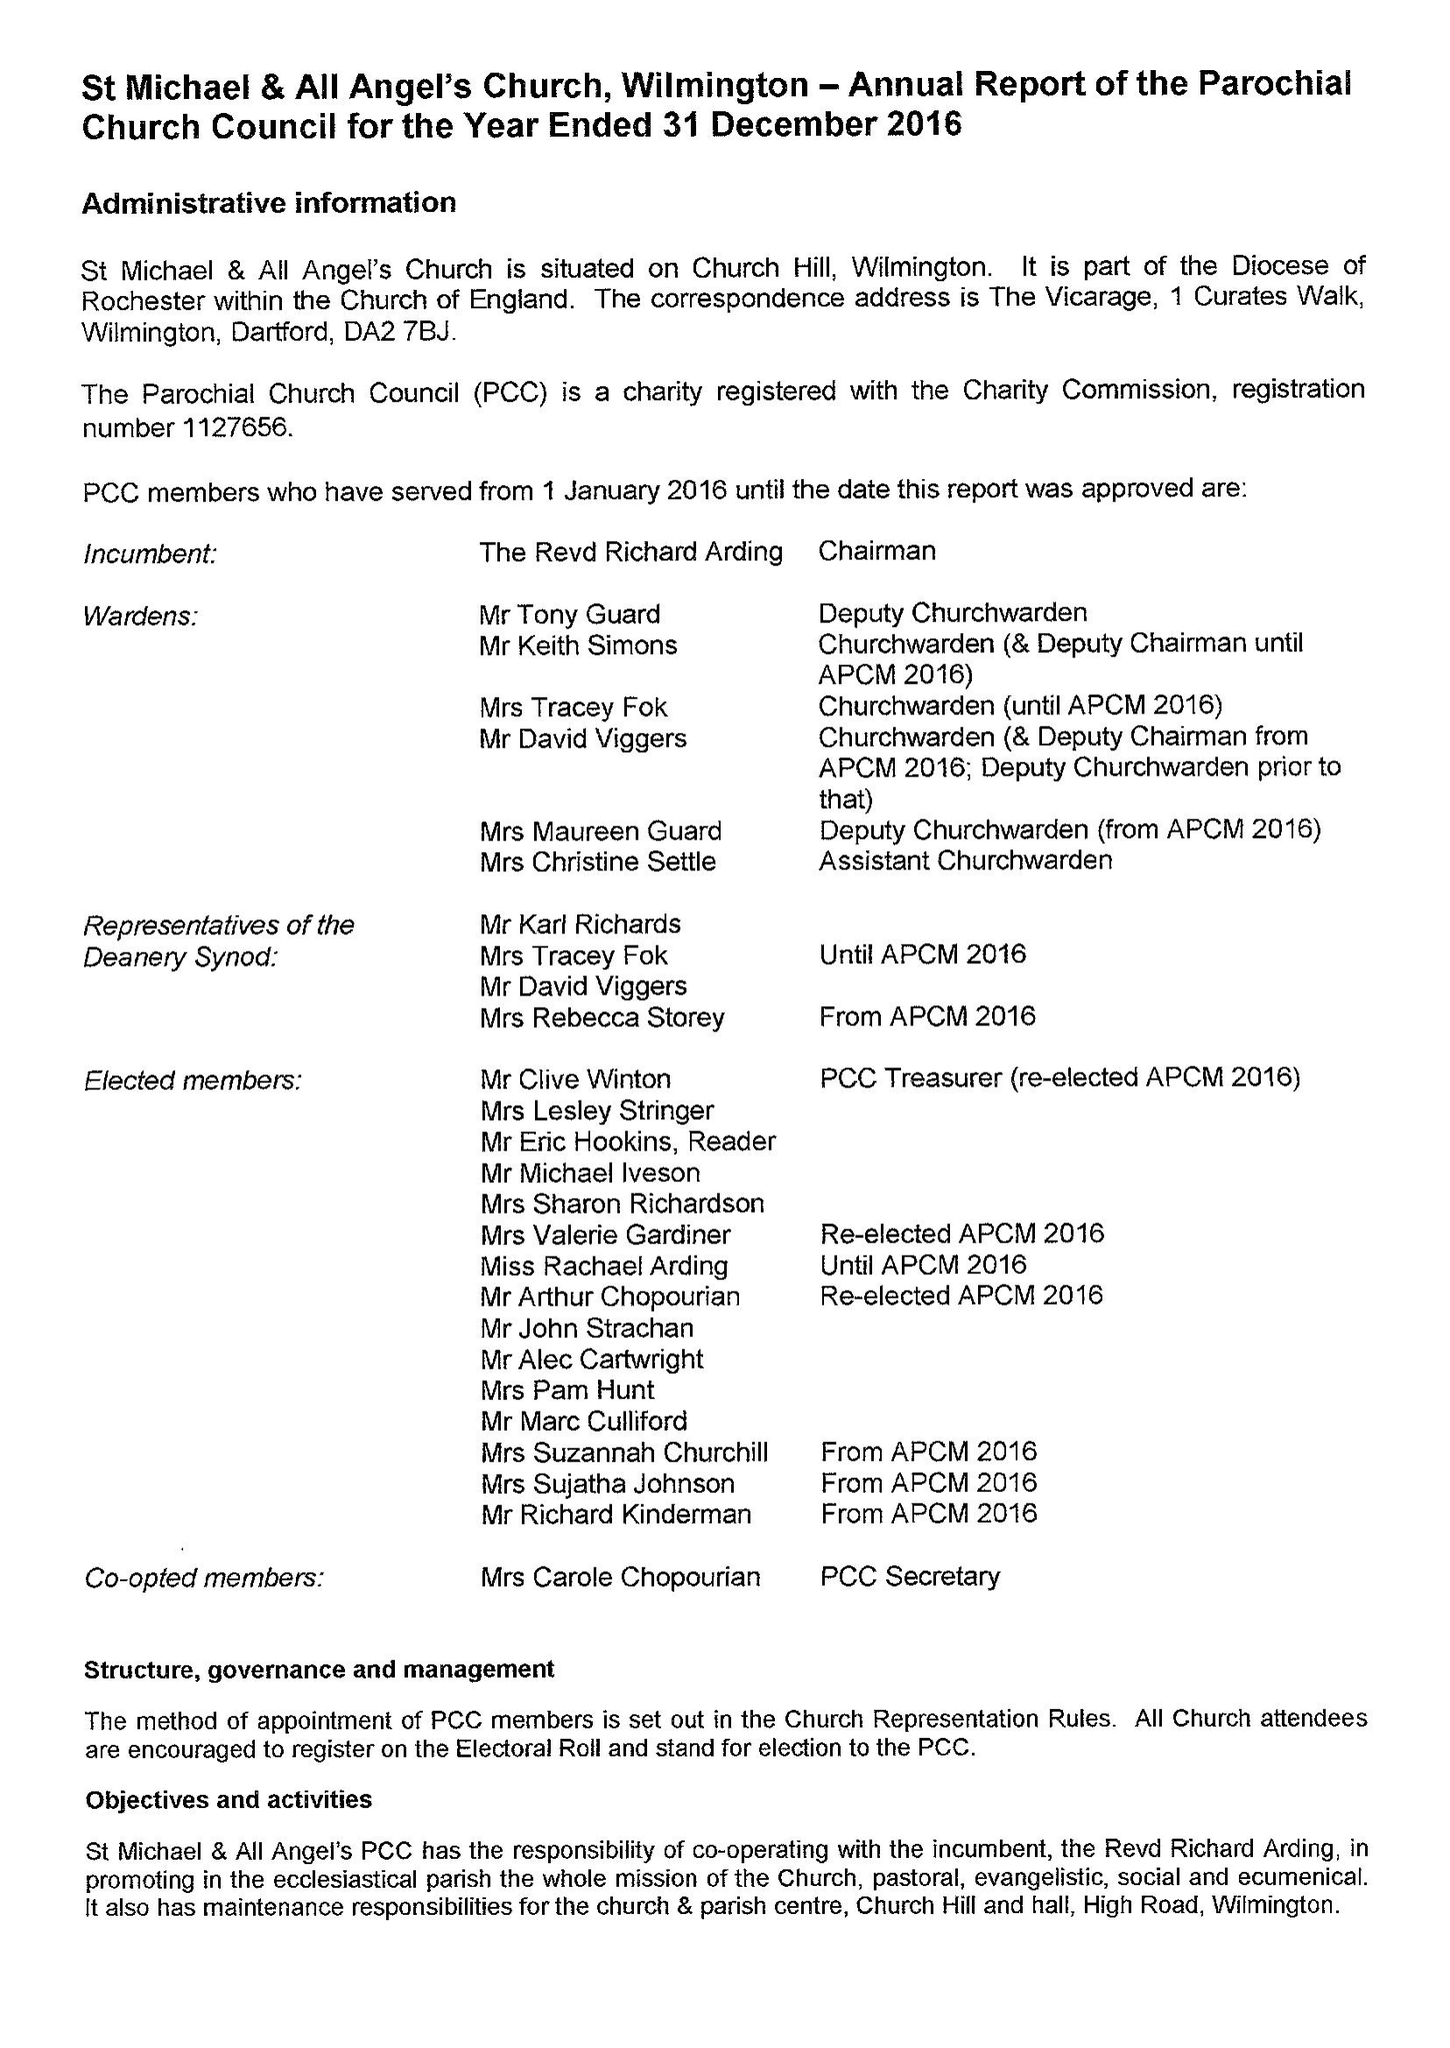What is the value for the address__postcode?
Answer the question using a single word or phrase. DA2 7EG 